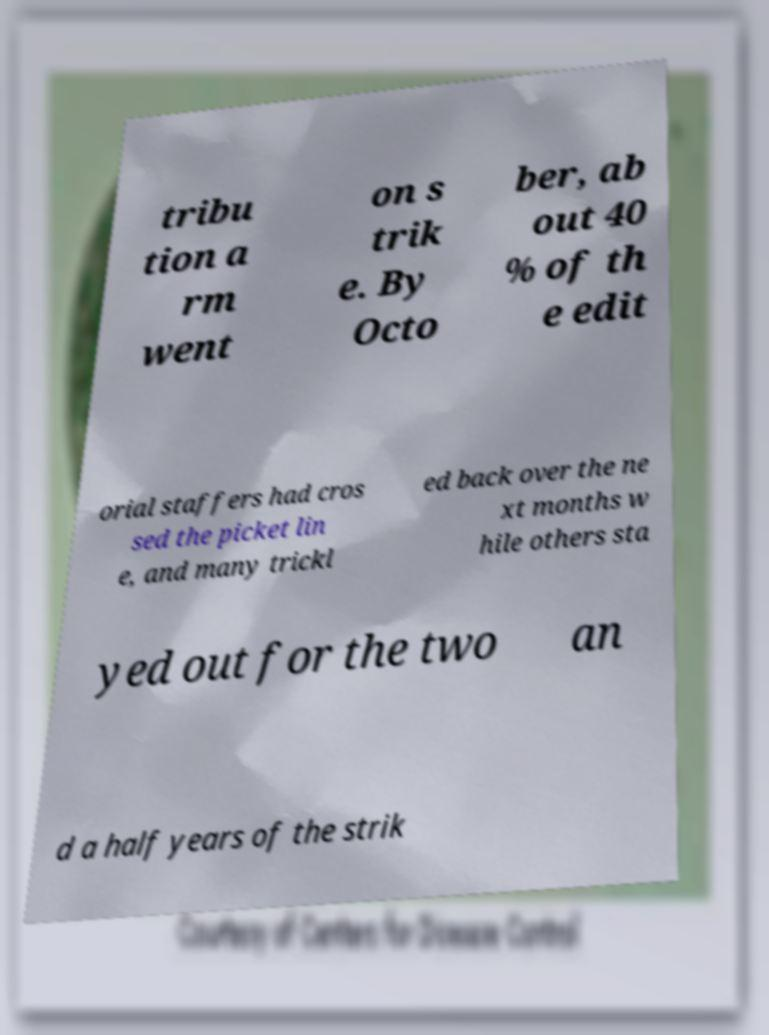For documentation purposes, I need the text within this image transcribed. Could you provide that? tribu tion a rm went on s trik e. By Octo ber, ab out 40 % of th e edit orial staffers had cros sed the picket lin e, and many trickl ed back over the ne xt months w hile others sta yed out for the two an d a half years of the strik 